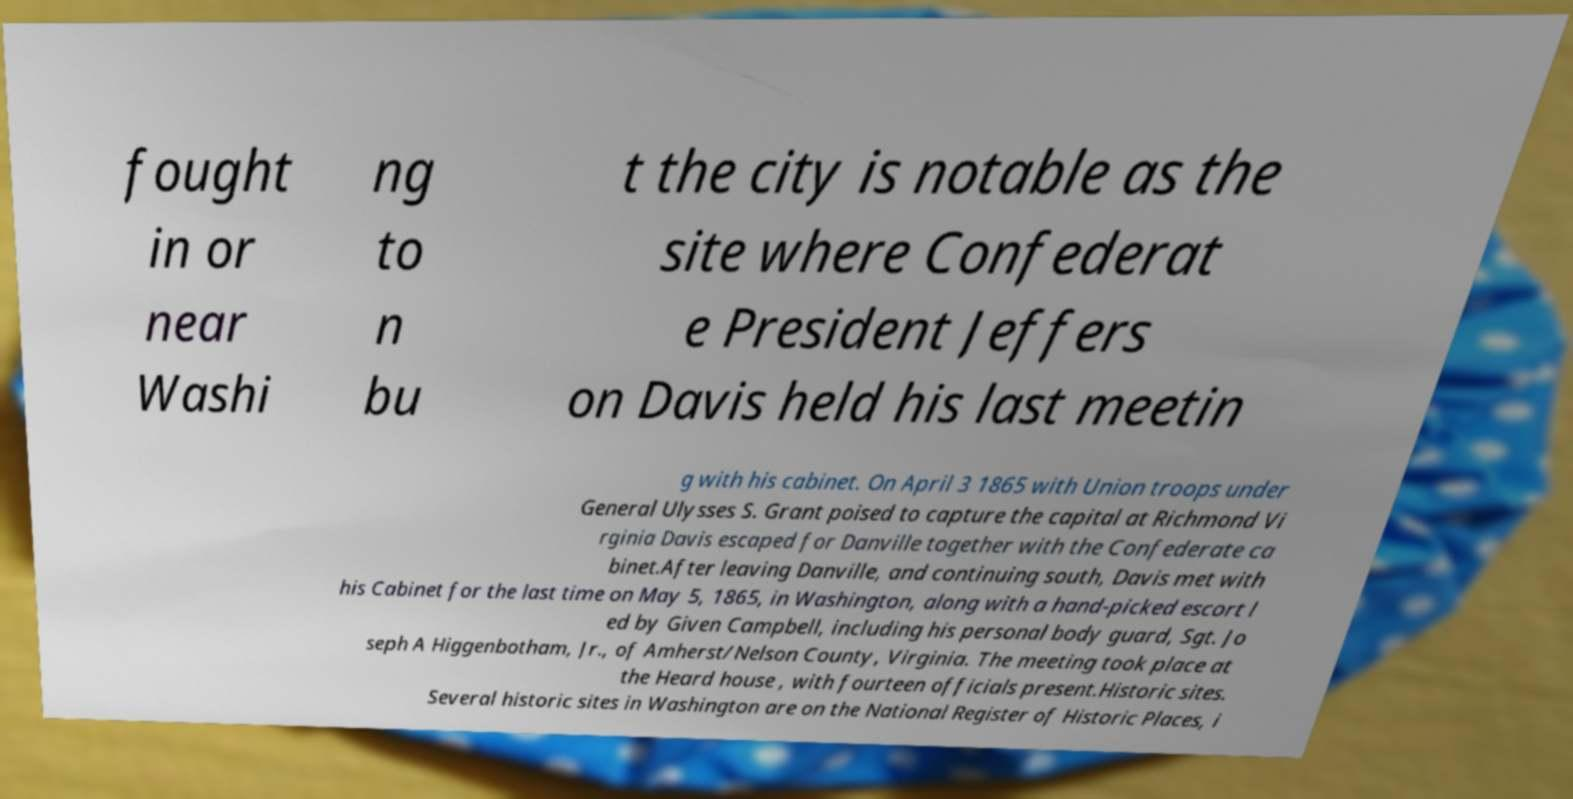Could you extract and type out the text from this image? fought in or near Washi ng to n bu t the city is notable as the site where Confederat e President Jeffers on Davis held his last meetin g with his cabinet. On April 3 1865 with Union troops under General Ulysses S. Grant poised to capture the capital at Richmond Vi rginia Davis escaped for Danville together with the Confederate ca binet.After leaving Danville, and continuing south, Davis met with his Cabinet for the last time on May 5, 1865, in Washington, along with a hand-picked escort l ed by Given Campbell, including his personal body guard, Sgt. Jo seph A Higgenbotham, Jr., of Amherst/Nelson County, Virginia. The meeting took place at the Heard house , with fourteen officials present.Historic sites. Several historic sites in Washington are on the National Register of Historic Places, i 